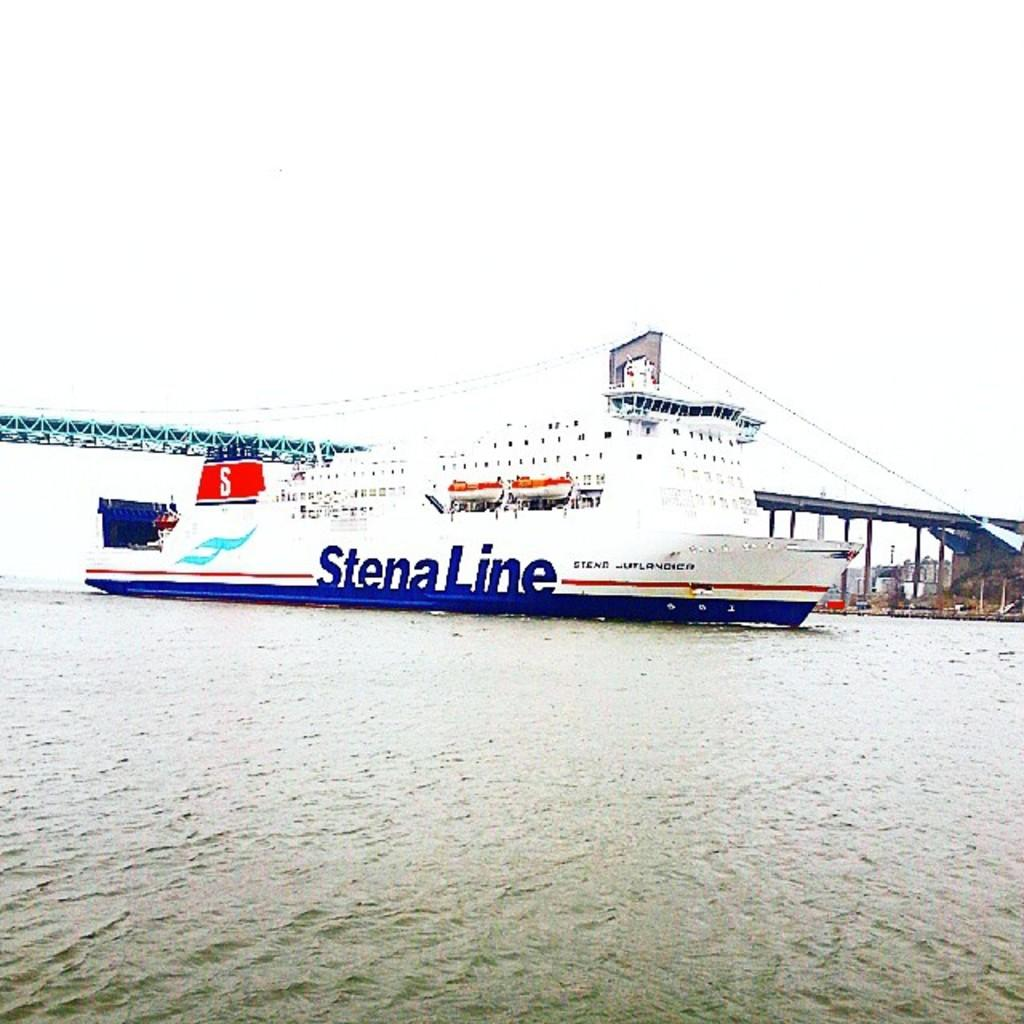What is the main subject of the image? The main subject of the image is water. What can be seen floating on the water? There is a boat in the image. What structure is visible in the image? There is a bridge in the image. What is visible above the water and the boat? The sky is visible in the image. Where is the lettuce growing in the image? There is no lettuce present in the image. Can you tell me who gave birth in the image? There is no birth or any indication of a person giving birth in the image. 